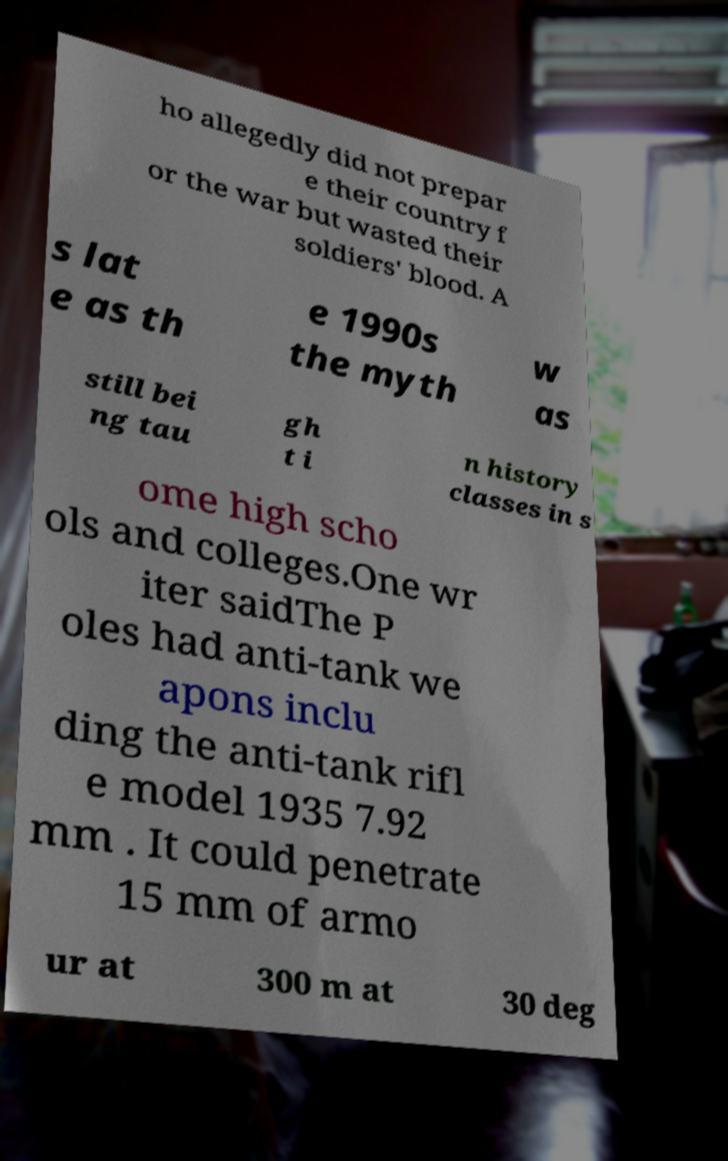What messages or text are displayed in this image? I need them in a readable, typed format. ho allegedly did not prepar e their country f or the war but wasted their soldiers' blood. A s lat e as th e 1990s the myth w as still bei ng tau gh t i n history classes in s ome high scho ols and colleges.One wr iter saidThe P oles had anti-tank we apons inclu ding the anti-tank rifl e model 1935 7.92 mm . It could penetrate 15 mm of armo ur at 300 m at 30 deg 